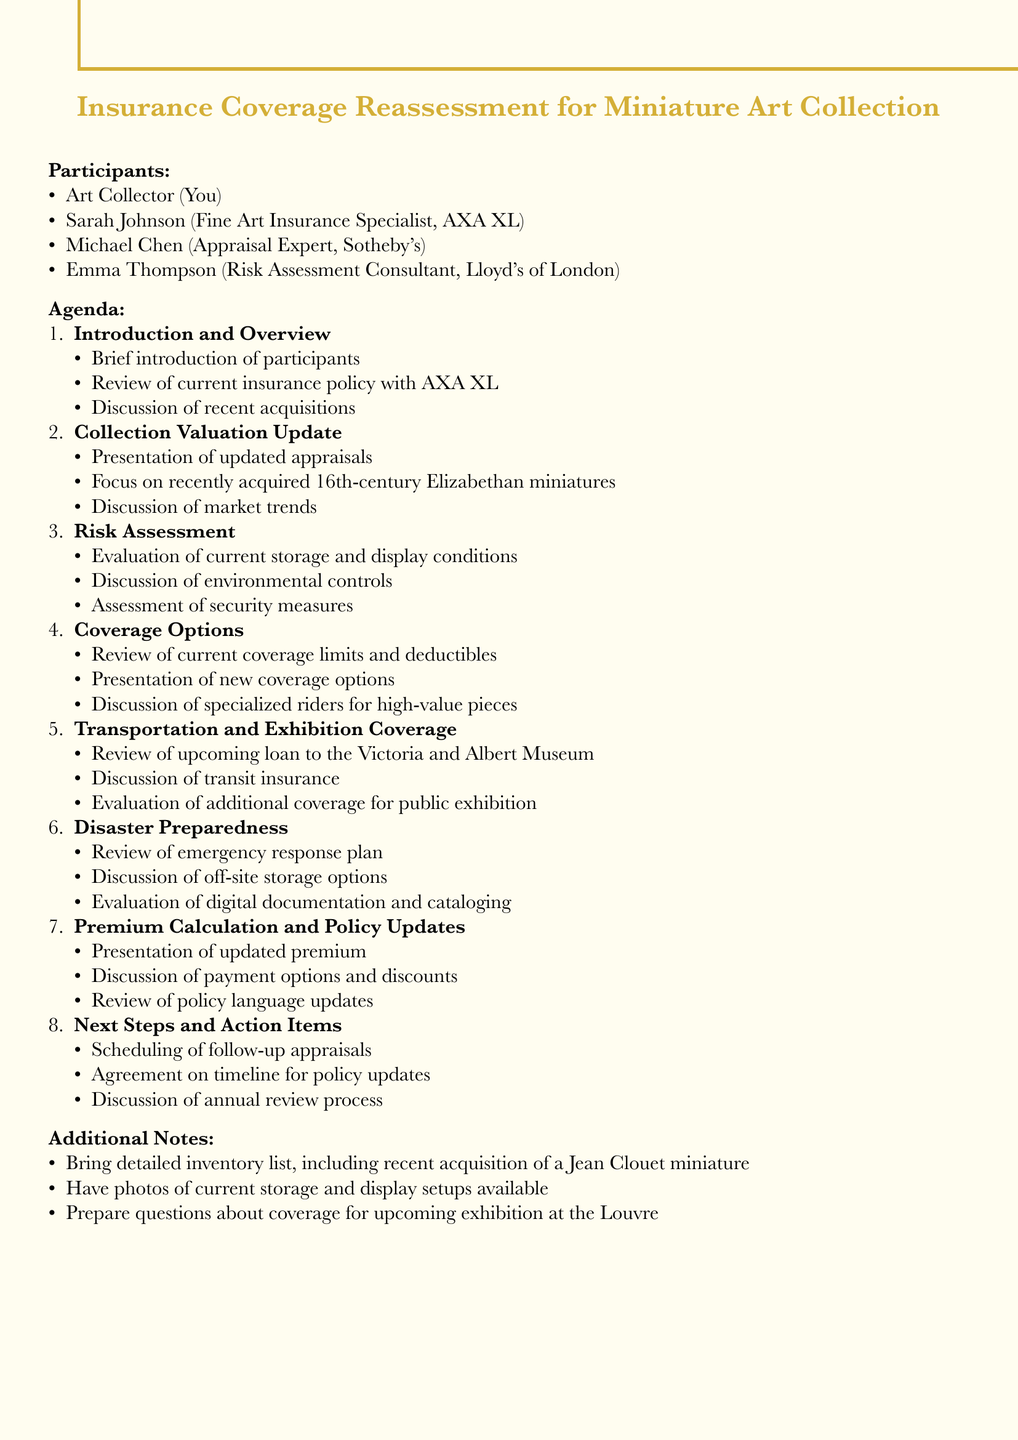What is the meeting title? The meeting title is clearly stated at the beginning of the document.
Answer: Insurance Coverage Reassessment for Miniature Art Collection Who is the appraisal expert? The document lists participants, including their roles.
Answer: Michael Chen What recent acquisitions are mentioned? The agenda discusses recent acquisitions under the introduction section.
Answer: Nicholas Hilliard and Isaac Oliver What is the focus of the collection valuation update? The agenda item specifies the focus area for collection valuation.
Answer: Recently acquired 16th-century Elizabethan miniatures What security measures are being assessed? The risk assessment section mentions security measures in the gallery.
Answer: Chubb security system How many topics are covered in the agenda? The number of distinct topics is listed in the agenda.
Answer: Eight What is being reviewed for the upcoming loan? The document mentions a specific event related to the collection.
Answer: Loan to the Victoria and Albert Museum What type of options will be presented by Sarah Johnson? The coverage options section notes who will present new options.
Answer: New coverage options What additional materials should be brought to the meeting? The additional notes offer guidance on preparation for the meeting.
Answer: Detailed inventory list 